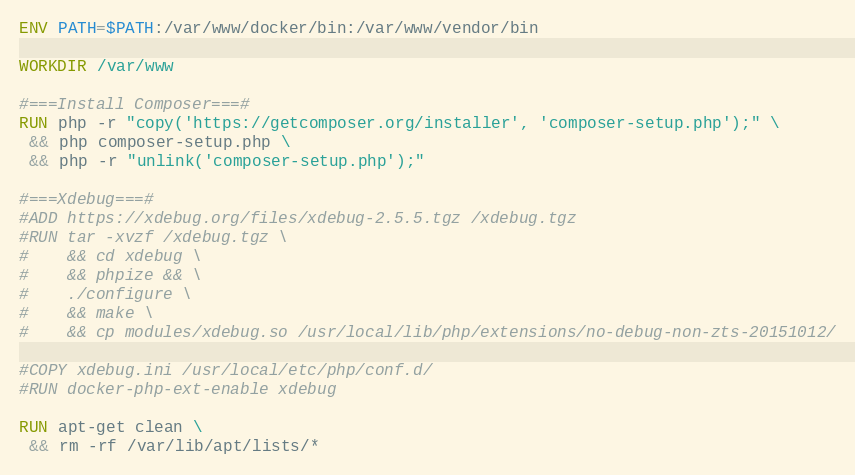Convert code to text. <code><loc_0><loc_0><loc_500><loc_500><_Dockerfile_>
ENV PATH=$PATH:/var/www/docker/bin:/var/www/vendor/bin

WORKDIR /var/www

#===Install Composer===#
RUN php -r "copy('https://getcomposer.org/installer', 'composer-setup.php');" \
 && php composer-setup.php \
 && php -r "unlink('composer-setup.php');"

#===Xdebug===#
#ADD https://xdebug.org/files/xdebug-2.5.5.tgz /xdebug.tgz
#RUN tar -xvzf /xdebug.tgz \
#    && cd xdebug \
#    && phpize && \
#    ./configure \
#    && make \
#    && cp modules/xdebug.so /usr/local/lib/php/extensions/no-debug-non-zts-20151012/

#COPY xdebug.ini /usr/local/etc/php/conf.d/
#RUN docker-php-ext-enable xdebug

RUN apt-get clean \
 && rm -rf /var/lib/apt/lists/*
</code> 